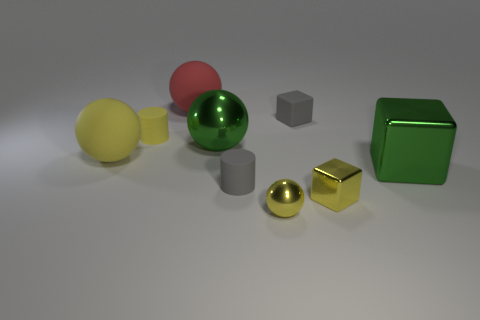Do the tiny shiny ball and the small metal block have the same color?
Provide a succinct answer. Yes. There is a big shiny thing that is right of the small metallic sphere; is its color the same as the large metallic ball?
Ensure brevity in your answer.  Yes. There is another yellow thing that is the same shape as the large yellow object; what is its size?
Your answer should be compact. Small. There is a small rubber thing to the right of the matte cylinder in front of the big yellow rubber ball; what is its color?
Provide a succinct answer. Gray. How many other things are there of the same material as the big red thing?
Offer a terse response. 4. There is a green thing that is right of the large metallic sphere; what number of large shiny balls are in front of it?
Keep it short and to the point. 0. There is a shiny cube that is behind the small gray cylinder; is its color the same as the ball that is behind the rubber cube?
Give a very brief answer. No. Are there fewer small matte objects than gray matte blocks?
Give a very brief answer. No. What is the shape of the small gray rubber object that is behind the cylinder to the right of the small yellow rubber object?
Offer a terse response. Cube. What is the shape of the big matte thing in front of the big matte object that is behind the yellow sphere that is behind the tiny shiny block?
Ensure brevity in your answer.  Sphere. 